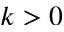<formula> <loc_0><loc_0><loc_500><loc_500>k > 0</formula> 